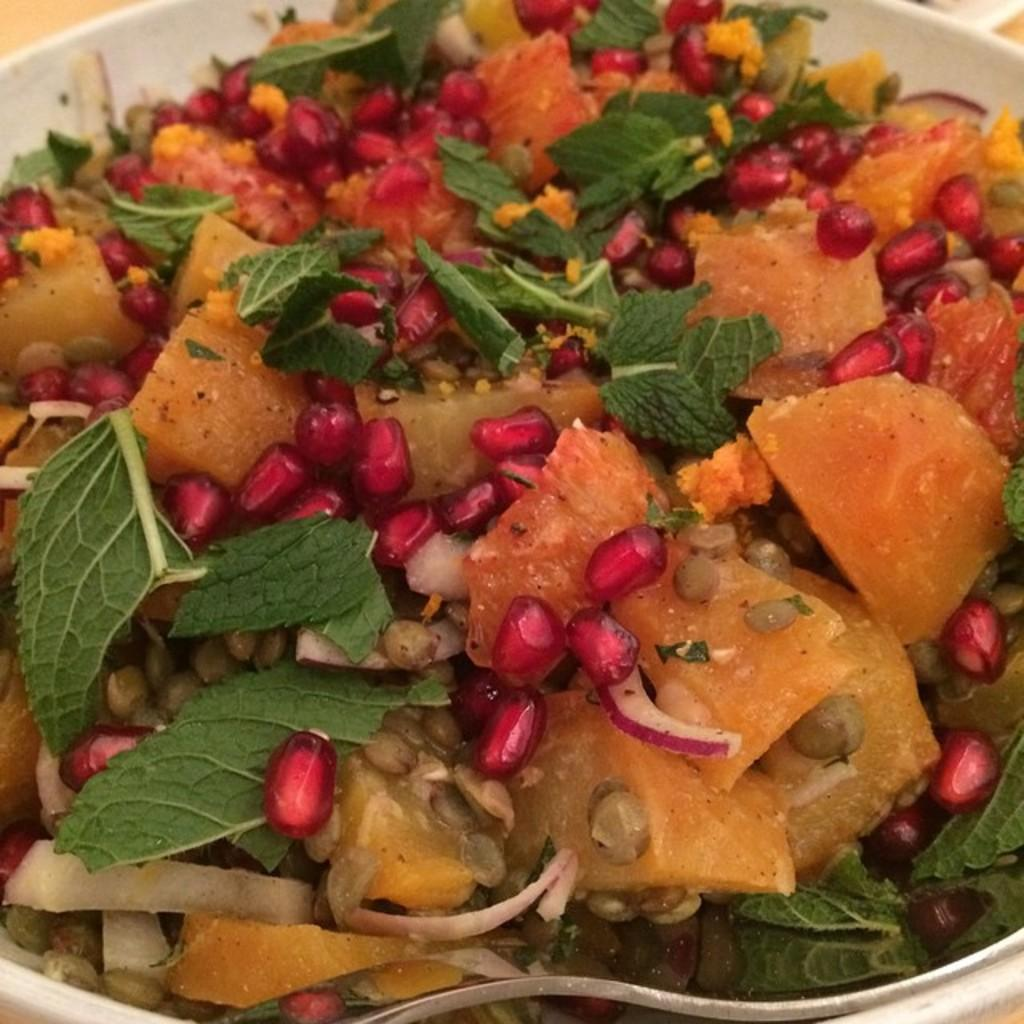What is the main subject of the image? There is a food item in the image. What utensil is present in the image? There is a spoon in the image. Where are the food item and spoon located? Both the food item and spoon are in a bowl. What type of army is depicted in the image? There is no army present in the image; it features a food item and a spoon in a bowl. What is the end result of the food item in the image? The image does not depict an end result for the food item; it simply shows the food item and spoon in a bowl. 